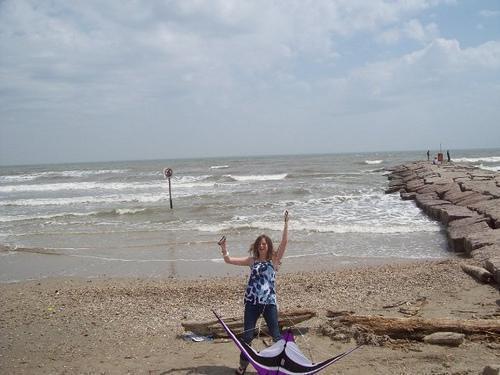What activity is she participating in?
Make your selection from the four choices given to correctly answer the question.
Options: Swimming, frisbee, kite flying, fishing. Kite flying. 